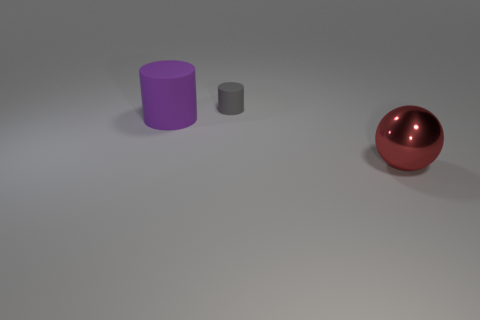Add 2 matte things. How many objects exist? 5 Subtract all balls. How many objects are left? 2 Subtract 1 purple cylinders. How many objects are left? 2 Subtract all large red spheres. Subtract all large purple rubber cylinders. How many objects are left? 1 Add 2 rubber cylinders. How many rubber cylinders are left? 4 Add 1 tiny red matte things. How many tiny red matte things exist? 1 